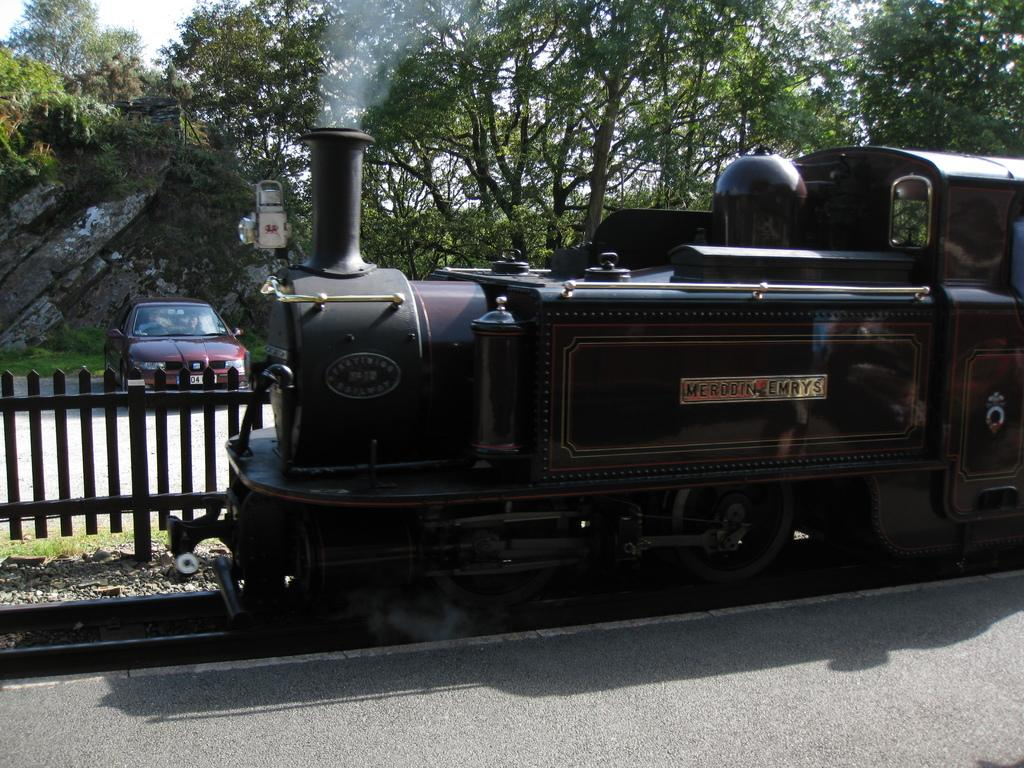What is the main subject in the middle of the image? There is a train in the middle of the image. What type of vehicle is parked on the left side of the image? There is a dark red color car parked on the left side of the image. What can be seen in the background of the image? A: There are green trees in the background of the image. What hobbies are the trees participating in during the image? Trees do not have hobbies, as they are inanimate objects. 